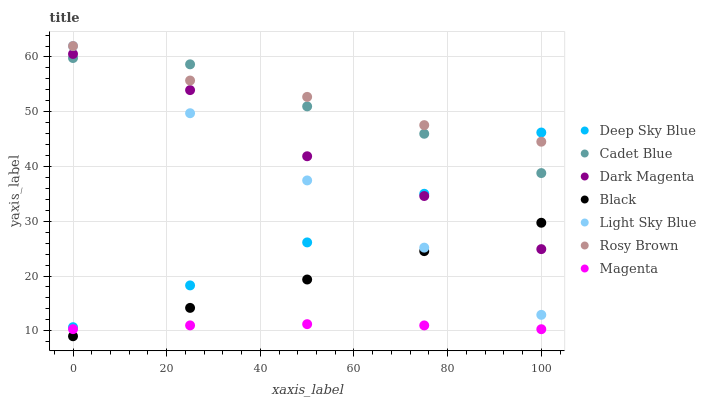Does Magenta have the minimum area under the curve?
Answer yes or no. Yes. Does Rosy Brown have the maximum area under the curve?
Answer yes or no. Yes. Does Dark Magenta have the minimum area under the curve?
Answer yes or no. No. Does Dark Magenta have the maximum area under the curve?
Answer yes or no. No. Is Black the smoothest?
Answer yes or no. Yes. Is Dark Magenta the roughest?
Answer yes or no. Yes. Is Rosy Brown the smoothest?
Answer yes or no. No. Is Rosy Brown the roughest?
Answer yes or no. No. Does Black have the lowest value?
Answer yes or no. Yes. Does Dark Magenta have the lowest value?
Answer yes or no. No. Does Light Sky Blue have the highest value?
Answer yes or no. Yes. Does Dark Magenta have the highest value?
Answer yes or no. No. Is Black less than Cadet Blue?
Answer yes or no. Yes. Is Cadet Blue greater than Black?
Answer yes or no. Yes. Does Black intersect Dark Magenta?
Answer yes or no. Yes. Is Black less than Dark Magenta?
Answer yes or no. No. Is Black greater than Dark Magenta?
Answer yes or no. No. Does Black intersect Cadet Blue?
Answer yes or no. No. 